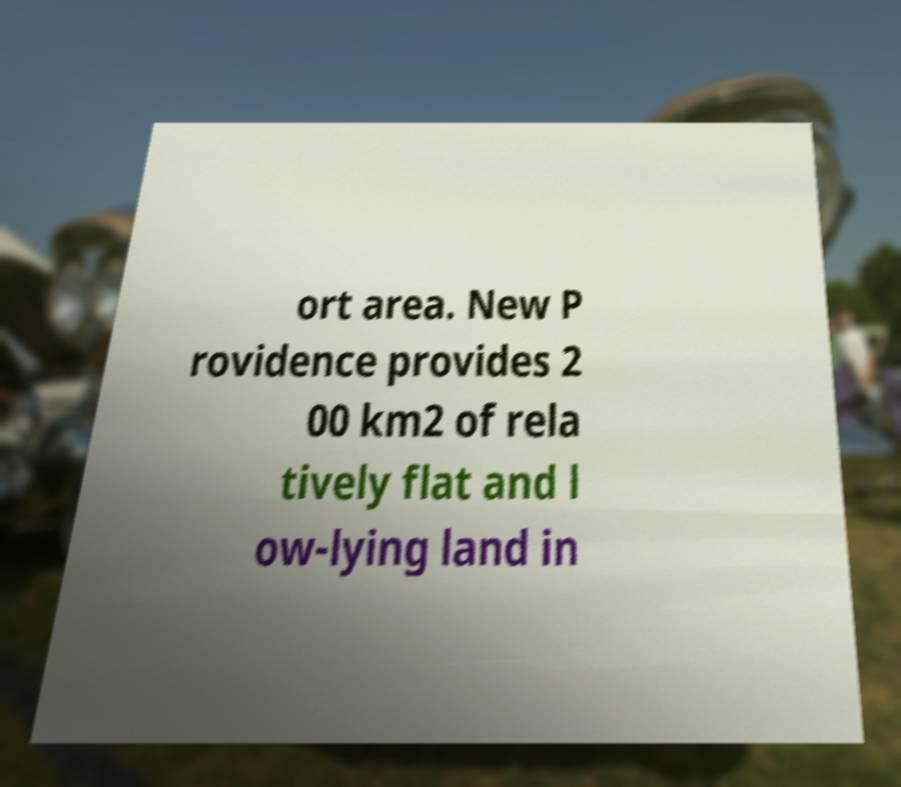Can you read and provide the text displayed in the image?This photo seems to have some interesting text. Can you extract and type it out for me? ort area. New P rovidence provides 2 00 km2 of rela tively flat and l ow-lying land in 